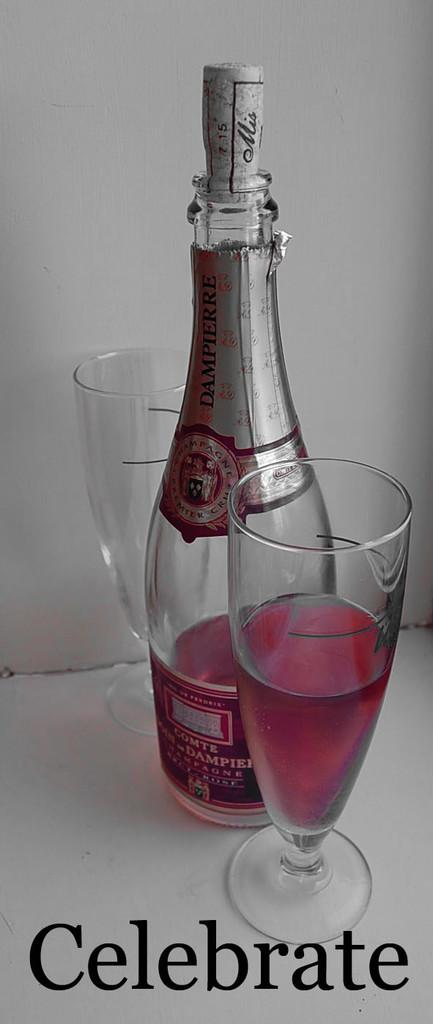What is in the bottle that has a label in the image? There is a bottle with a label in the image, but the contents are not specified. How many glasses are visible in the image? There are two glasses in the image. What is inside the glasses in the image? The glasses contain a drink. Can you tell me how many cows are drinking from the bottle in the image? There are no cows present in the image, and they are not drinking from the bottle. 